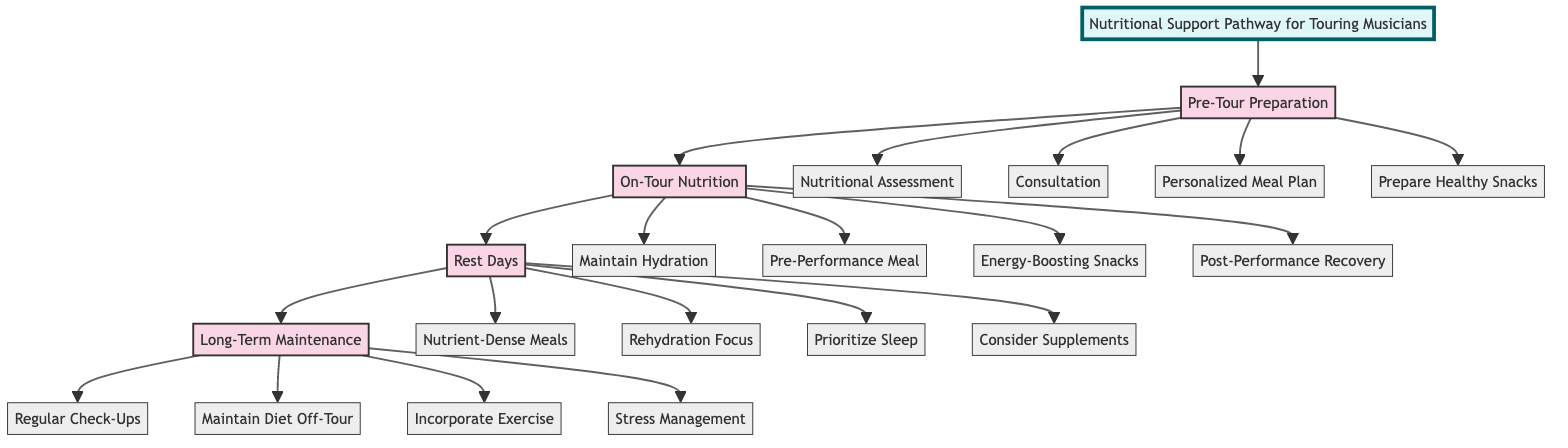What is the first stage of the Nutritional Support Pathway? The diagram clearly indicates that the first stage is labeled "Pre-Tour Preparation," which is visually represented at the top of the flowchart.
Answer: Pre-Tour Preparation How many key elements are listed under "On-Tour Nutrition"? By counting the listed elements under "On-Tour Nutrition," we find that there are four key elements: Maintain Hydration, Pre-Performance Meal, Energy-Boosting Snacks, and Post-Performance Recovery.
Answer: 4 What is included in the Rest Days stage for rehydration? The diagram specifies that "Rehydration: Focus on rehydrating" is a key element listed in the Rest Days section, emphasizing the importance of rehydration for musicians.
Answer: Rehydration: Focus on rehydrating What stage follows "On-Tour Nutrition"? According to the flowchart structure, the stage that directly follows "On-Tour Nutrition" is "Rest Days," illustrated by the flow connecting these two stages.
Answer: Rest Days Which key element in Long-Term Maintenance addresses mental health? The diagram mentions "Stress Management" in the Long-Term Maintenance stage as a crucial aspect for mental health support, highlighting its significance for touring musicians.
Answer: Stress Management What are the two key elements related to hydration in the entire pathway? The diagram outlines "Maintain Hydration" in the On-Tour Nutrition stage and "Rehydration: Focus on rehydrating" in the Rest Days stage, which both pertain to hydration throughout the pathway.
Answer: Maintain Hydration and Rehydration: Focus on rehydrating How many stages are in the Nutritional Support Pathway? By examining the top-level sections of the diagram, it's clear that there are four stages labeled: Pre-Tour Preparation, On-Tour Nutrition, Rest Days, and Long-Term Maintenance.
Answer: 4 What is the purpose of the Consultation element in the Pre-Tour Preparation stage? Referring to the diagram, "Consultation: Meet with a sports dietitian" is included in the Pre-Tour Preparation stage, indicating that its purpose is to obtain expert nutritional advice tailored for musicians.
Answer: Meet with a sports dietitian 